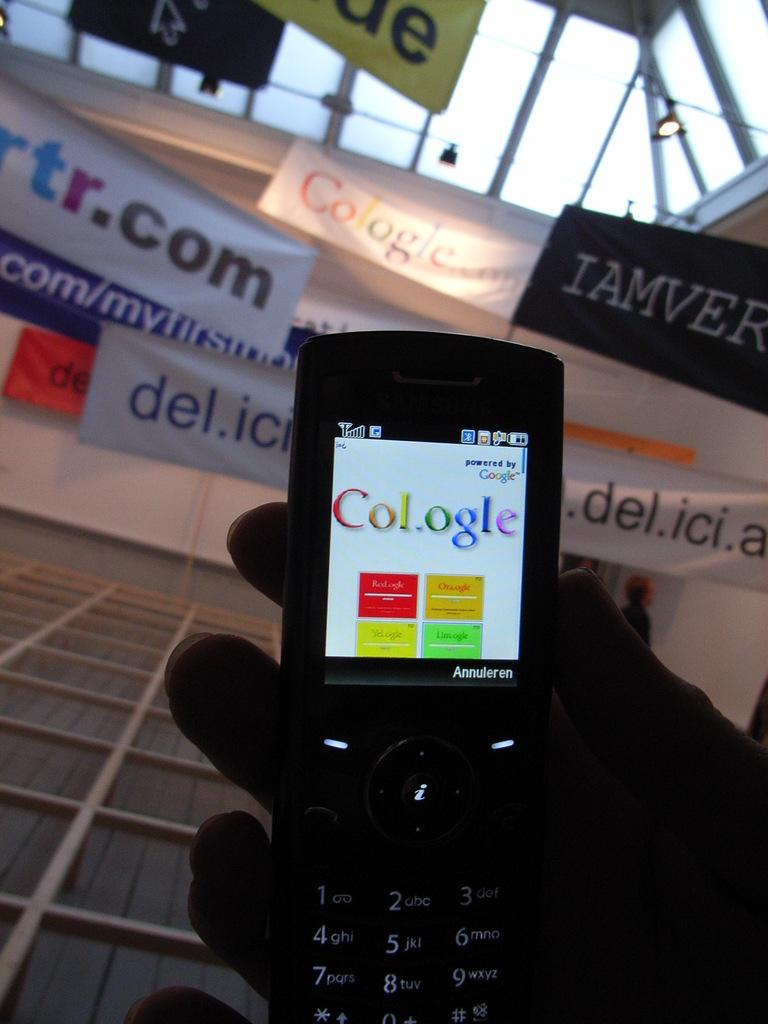Provide a one-sentence caption for the provided image. A flip phone has Col.ogle on its screen. 